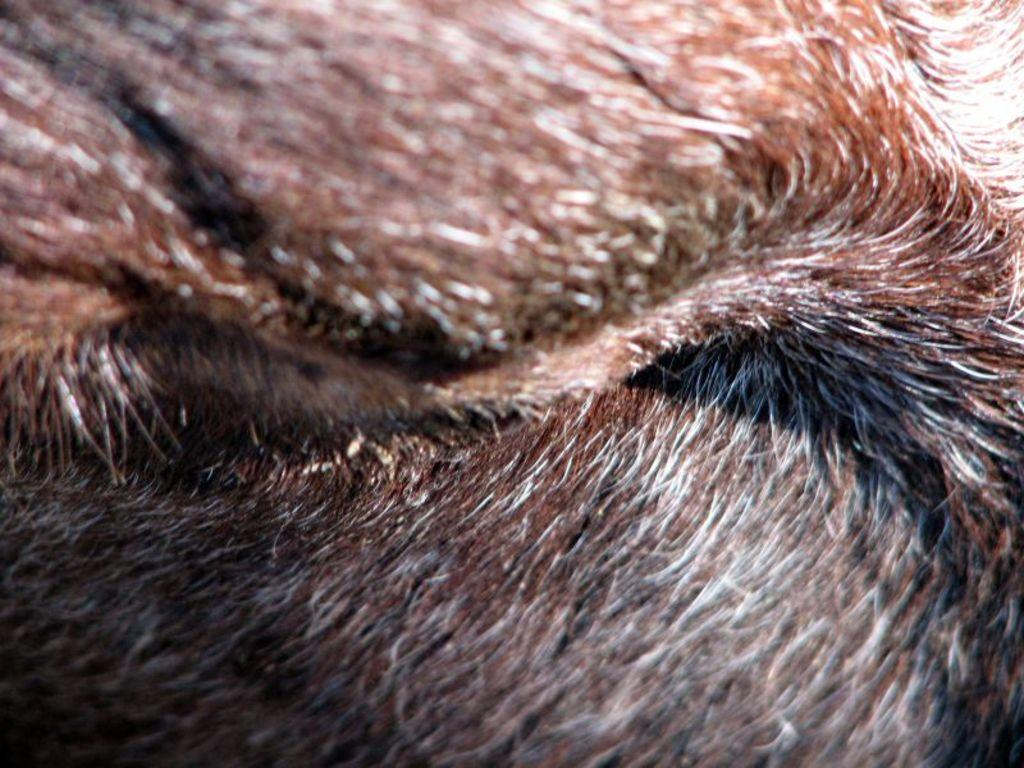What type of material is present in the image? There are hairs in the image. Can you describe the color of the hairs? The hairs are black in color. How many rabbits can be seen in the image? There are no rabbits present in the image; it only features hairs. What type of beast is visible in the image? There is no beast present in the image; it only features hairs. 